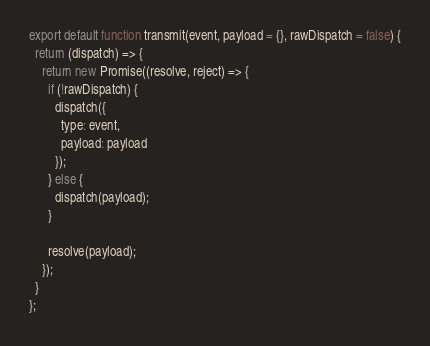Convert code to text. <code><loc_0><loc_0><loc_500><loc_500><_JavaScript_>export default function transmit(event, payload = {}, rawDispatch = false) {
  return (dispatch) => {
    return new Promise((resolve, reject) => {
      if (!rawDispatch) {
        dispatch({
          type: event,
          payload: payload
        });
      } else {
        dispatch(payload);
      }

      resolve(payload);
    });
  }
};
</code> 